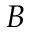Convert formula to latex. <formula><loc_0><loc_0><loc_500><loc_500>B</formula> 